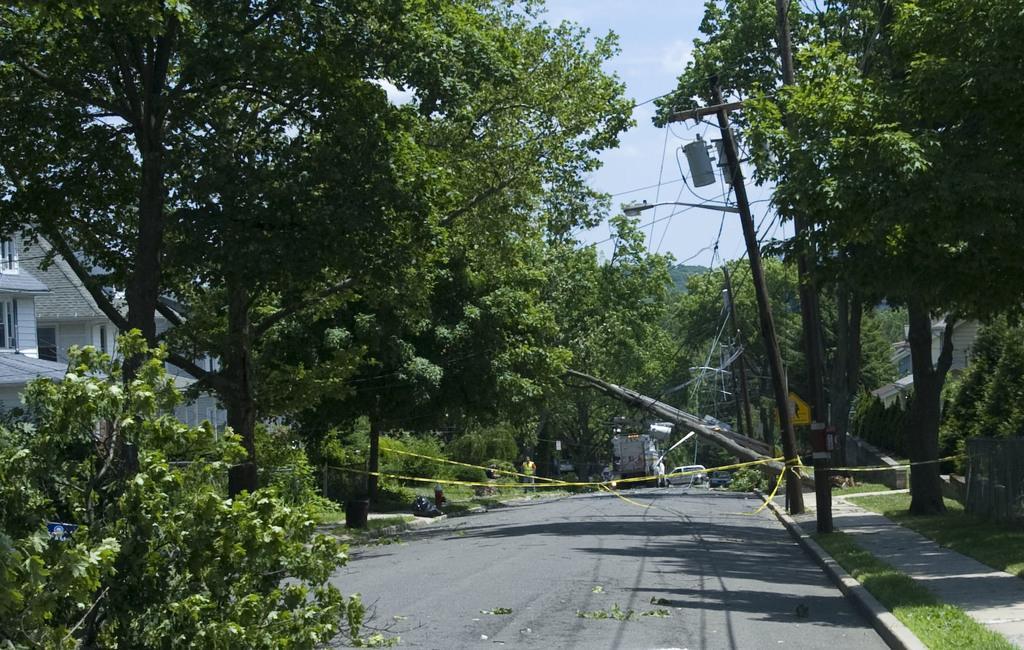Can you describe this image briefly? In this image I can see trees, light poles, fence, grass, vehicles on the road, wires and buildings. In the background I can see the sky. This image is taken may be during a day. 